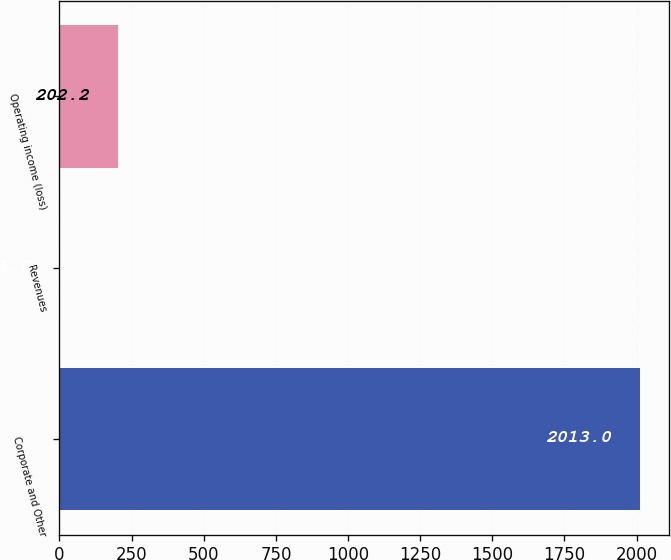Convert chart. <chart><loc_0><loc_0><loc_500><loc_500><bar_chart><fcel>Corporate and Other<fcel>Revenues<fcel>Operating income (loss)<nl><fcel>2013<fcel>1<fcel>202.2<nl></chart> 